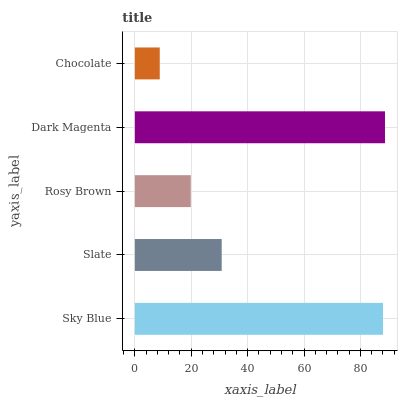Is Chocolate the minimum?
Answer yes or no. Yes. Is Dark Magenta the maximum?
Answer yes or no. Yes. Is Slate the minimum?
Answer yes or no. No. Is Slate the maximum?
Answer yes or no. No. Is Sky Blue greater than Slate?
Answer yes or no. Yes. Is Slate less than Sky Blue?
Answer yes or no. Yes. Is Slate greater than Sky Blue?
Answer yes or no. No. Is Sky Blue less than Slate?
Answer yes or no. No. Is Slate the high median?
Answer yes or no. Yes. Is Slate the low median?
Answer yes or no. Yes. Is Dark Magenta the high median?
Answer yes or no. No. Is Chocolate the low median?
Answer yes or no. No. 